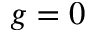<formula> <loc_0><loc_0><loc_500><loc_500>g = 0</formula> 